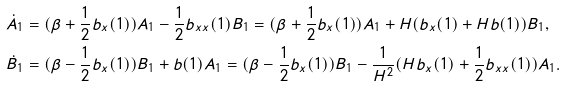<formula> <loc_0><loc_0><loc_500><loc_500>\dot { A } _ { 1 } & = ( \beta + \frac { 1 } { 2 } b _ { x } ( 1 ) ) A _ { 1 } - \frac { 1 } { 2 } b _ { x x } ( 1 ) B _ { 1 } = ( \beta + \frac { 1 } { 2 } b _ { x } ( 1 ) ) A _ { 1 } + H ( b _ { x } ( 1 ) + H b ( 1 ) ) B _ { 1 } , \\ \dot { B } _ { 1 } & = ( \beta - \frac { 1 } { 2 } b _ { x } ( 1 ) ) B _ { 1 } + b ( 1 ) A _ { 1 } = ( \beta - \frac { 1 } { 2 } b _ { x } ( 1 ) ) B _ { 1 } - \frac { 1 } { H ^ { 2 } } ( H b _ { x } ( 1 ) + \frac { 1 } { 2 } b _ { x x } ( 1 ) ) A _ { 1 } .</formula> 